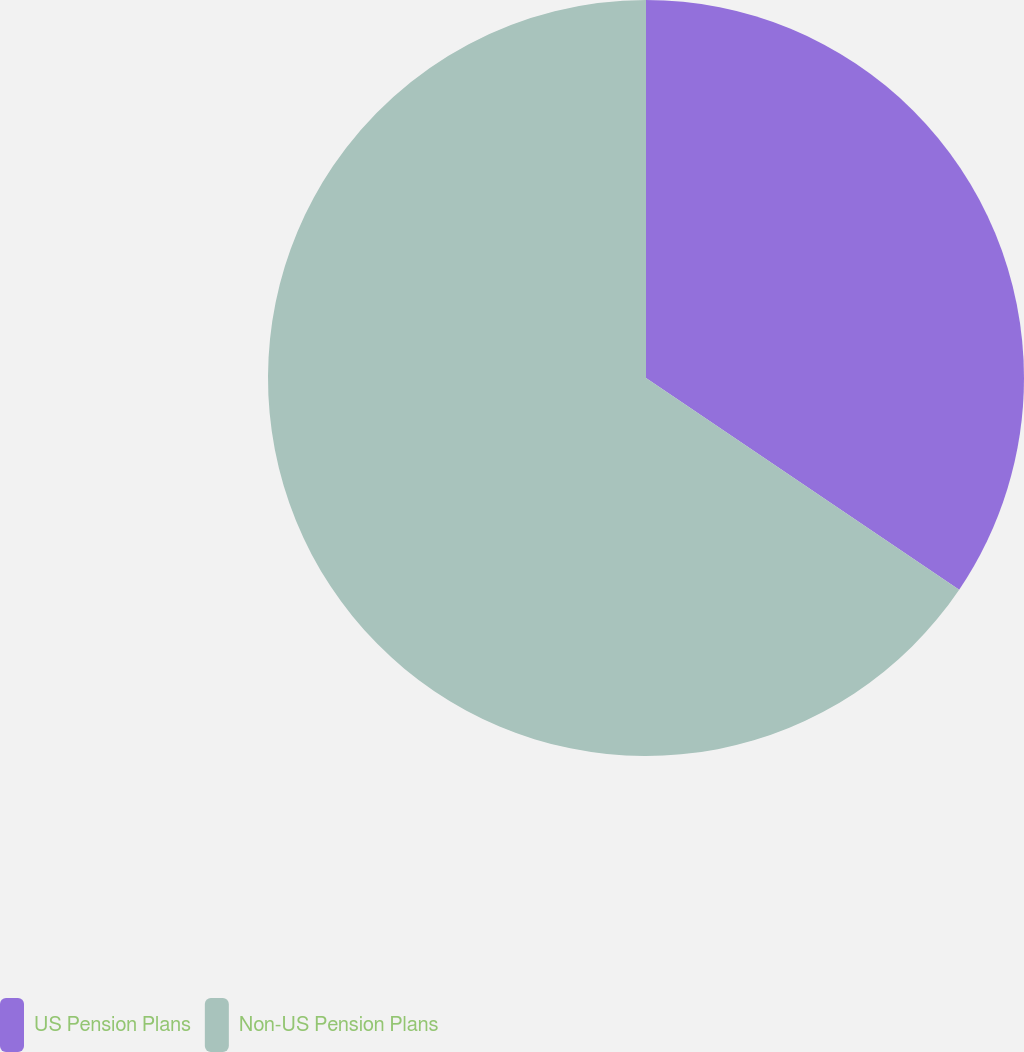<chart> <loc_0><loc_0><loc_500><loc_500><pie_chart><fcel>US Pension Plans<fcel>Non-US Pension Plans<nl><fcel>34.46%<fcel>65.54%<nl></chart> 